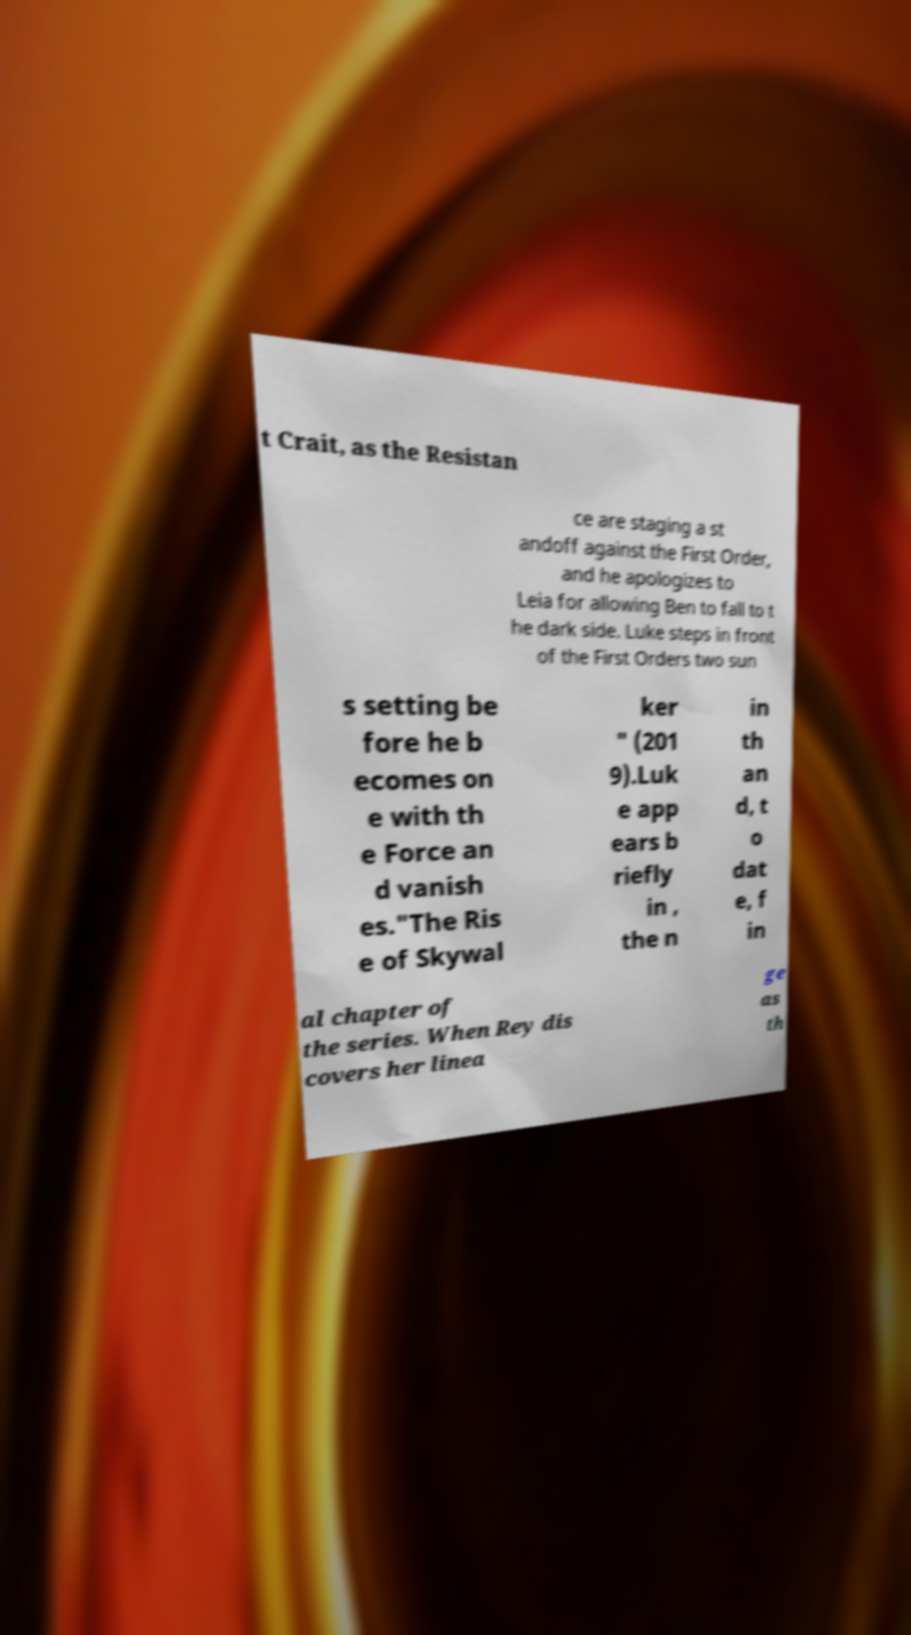I need the written content from this picture converted into text. Can you do that? t Crait, as the Resistan ce are staging a st andoff against the First Order, and he apologizes to Leia for allowing Ben to fall to t he dark side. Luke steps in front of the First Orders two sun s setting be fore he b ecomes on e with th e Force an d vanish es."The Ris e of Skywal ker " (201 9).Luk e app ears b riefly in , the n in th an d, t o dat e, f in al chapter of the series. When Rey dis covers her linea ge as th 